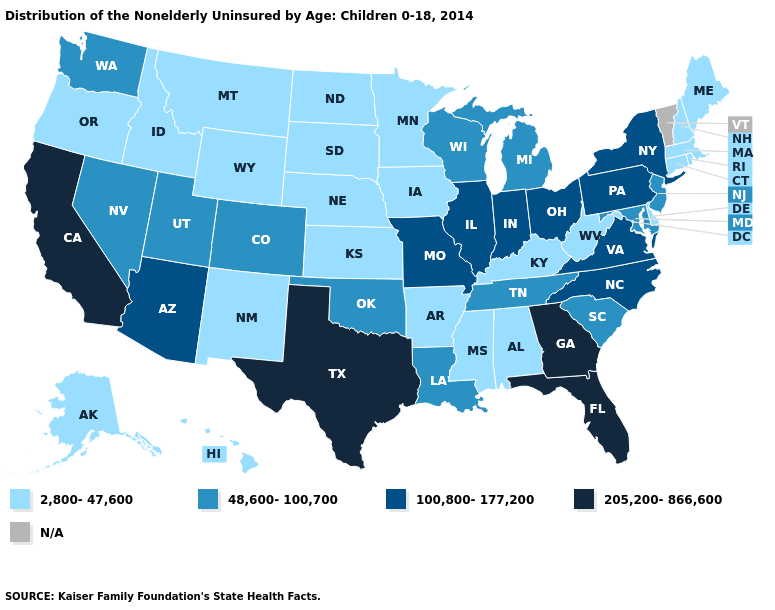Name the states that have a value in the range 100,800-177,200?
Quick response, please. Arizona, Illinois, Indiana, Missouri, New York, North Carolina, Ohio, Pennsylvania, Virginia. What is the highest value in states that border Tennessee?
Answer briefly. 205,200-866,600. Among the states that border Oklahoma , does Texas have the highest value?
Keep it brief. Yes. Does Texas have the highest value in the USA?
Be succinct. Yes. Is the legend a continuous bar?
Short answer required. No. Does Texas have the highest value in the USA?
Short answer required. Yes. Does North Carolina have the highest value in the USA?
Give a very brief answer. No. Which states hav the highest value in the West?
Write a very short answer. California. Among the states that border Michigan , does Wisconsin have the lowest value?
Be succinct. Yes. Name the states that have a value in the range 48,600-100,700?
Give a very brief answer. Colorado, Louisiana, Maryland, Michigan, Nevada, New Jersey, Oklahoma, South Carolina, Tennessee, Utah, Washington, Wisconsin. Name the states that have a value in the range 100,800-177,200?
Be succinct. Arizona, Illinois, Indiana, Missouri, New York, North Carolina, Ohio, Pennsylvania, Virginia. Among the states that border Delaware , which have the highest value?
Keep it brief. Pennsylvania. Which states have the lowest value in the MidWest?
Concise answer only. Iowa, Kansas, Minnesota, Nebraska, North Dakota, South Dakota. Does the first symbol in the legend represent the smallest category?
Short answer required. Yes. 